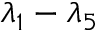<formula> <loc_0><loc_0><loc_500><loc_500>\lambda _ { 1 } - \lambda _ { 5 }</formula> 